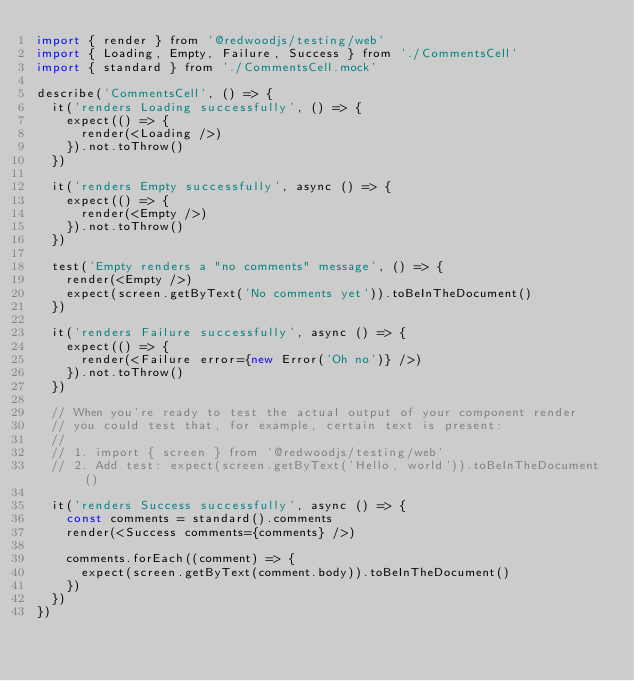Convert code to text. <code><loc_0><loc_0><loc_500><loc_500><_JavaScript_>import { render } from '@redwoodjs/testing/web'
import { Loading, Empty, Failure, Success } from './CommentsCell'
import { standard } from './CommentsCell.mock'

describe('CommentsCell', () => {
  it('renders Loading successfully', () => {
    expect(() => {
      render(<Loading />)
    }).not.toThrow()
  })

  it('renders Empty successfully', async () => {
    expect(() => {
      render(<Empty />)
    }).not.toThrow()
  })

  test('Empty renders a "no comments" message', () => {
    render(<Empty />)
    expect(screen.getByText('No comments yet')).toBeInTheDocument()
  })

  it('renders Failure successfully', async () => {
    expect(() => {
      render(<Failure error={new Error('Oh no')} />)
    }).not.toThrow()
  })

  // When you're ready to test the actual output of your component render
  // you could test that, for example, certain text is present:
  //
  // 1. import { screen } from '@redwoodjs/testing/web'
  // 2. Add test: expect(screen.getByText('Hello, world')).toBeInTheDocument()

  it('renders Success successfully', async () => {
    const comments = standard().comments
    render(<Success comments={comments} />)

    comments.forEach((comment) => {
      expect(screen.getByText(comment.body)).toBeInTheDocument()
    })
  })
})
</code> 